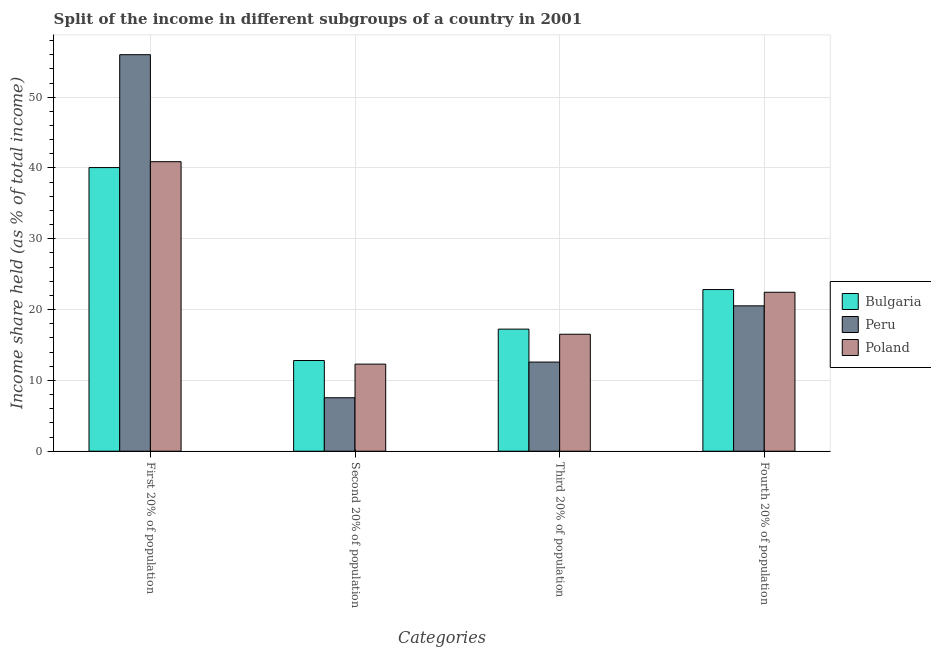Are the number of bars on each tick of the X-axis equal?
Give a very brief answer. Yes. How many bars are there on the 3rd tick from the left?
Your response must be concise. 3. How many bars are there on the 3rd tick from the right?
Provide a succinct answer. 3. What is the label of the 2nd group of bars from the left?
Your answer should be very brief. Second 20% of population. What is the share of the income held by third 20% of the population in Peru?
Your answer should be very brief. 12.59. Across all countries, what is the minimum share of the income held by third 20% of the population?
Provide a short and direct response. 12.59. In which country was the share of the income held by second 20% of the population maximum?
Give a very brief answer. Bulgaria. What is the total share of the income held by second 20% of the population in the graph?
Provide a succinct answer. 32.66. What is the difference between the share of the income held by first 20% of the population in Peru and that in Poland?
Your answer should be compact. 15.11. What is the difference between the share of the income held by fourth 20% of the population in Bulgaria and the share of the income held by third 20% of the population in Poland?
Your answer should be very brief. 6.31. What is the average share of the income held by third 20% of the population per country?
Give a very brief answer. 15.45. What is the difference between the share of the income held by third 20% of the population and share of the income held by second 20% of the population in Poland?
Give a very brief answer. 4.22. What is the ratio of the share of the income held by third 20% of the population in Bulgaria to that in Poland?
Your answer should be compact. 1.04. Is the share of the income held by second 20% of the population in Poland less than that in Peru?
Your response must be concise. No. Is the difference between the share of the income held by fourth 20% of the population in Bulgaria and Peru greater than the difference between the share of the income held by second 20% of the population in Bulgaria and Peru?
Offer a very short reply. No. What is the difference between the highest and the second highest share of the income held by first 20% of the population?
Your response must be concise. 15.11. What is the difference between the highest and the lowest share of the income held by first 20% of the population?
Your answer should be very brief. 15.94. In how many countries, is the share of the income held by first 20% of the population greater than the average share of the income held by first 20% of the population taken over all countries?
Your answer should be compact. 1. Is the sum of the share of the income held by first 20% of the population in Peru and Bulgaria greater than the maximum share of the income held by second 20% of the population across all countries?
Give a very brief answer. Yes. What does the 2nd bar from the right in First 20% of population represents?
Your answer should be very brief. Peru. How many bars are there?
Keep it short and to the point. 12. Are the values on the major ticks of Y-axis written in scientific E-notation?
Make the answer very short. No. How many legend labels are there?
Keep it short and to the point. 3. What is the title of the graph?
Keep it short and to the point. Split of the income in different subgroups of a country in 2001. What is the label or title of the X-axis?
Your answer should be very brief. Categories. What is the label or title of the Y-axis?
Ensure brevity in your answer.  Income share held (as % of total income). What is the Income share held (as % of total income) in Bulgaria in First 20% of population?
Provide a short and direct response. 40.06. What is the Income share held (as % of total income) in Poland in First 20% of population?
Ensure brevity in your answer.  40.89. What is the Income share held (as % of total income) in Bulgaria in Second 20% of population?
Offer a very short reply. 12.81. What is the Income share held (as % of total income) of Peru in Second 20% of population?
Make the answer very short. 7.55. What is the Income share held (as % of total income) in Bulgaria in Third 20% of population?
Provide a succinct answer. 17.24. What is the Income share held (as % of total income) in Peru in Third 20% of population?
Ensure brevity in your answer.  12.59. What is the Income share held (as % of total income) of Poland in Third 20% of population?
Offer a very short reply. 16.52. What is the Income share held (as % of total income) of Bulgaria in Fourth 20% of population?
Keep it short and to the point. 22.83. What is the Income share held (as % of total income) in Peru in Fourth 20% of population?
Your response must be concise. 20.53. What is the Income share held (as % of total income) of Poland in Fourth 20% of population?
Your response must be concise. 22.45. Across all Categories, what is the maximum Income share held (as % of total income) of Bulgaria?
Ensure brevity in your answer.  40.06. Across all Categories, what is the maximum Income share held (as % of total income) in Peru?
Keep it short and to the point. 56. Across all Categories, what is the maximum Income share held (as % of total income) of Poland?
Offer a terse response. 40.89. Across all Categories, what is the minimum Income share held (as % of total income) in Bulgaria?
Give a very brief answer. 12.81. Across all Categories, what is the minimum Income share held (as % of total income) in Peru?
Ensure brevity in your answer.  7.55. What is the total Income share held (as % of total income) in Bulgaria in the graph?
Provide a succinct answer. 92.94. What is the total Income share held (as % of total income) of Peru in the graph?
Give a very brief answer. 96.67. What is the total Income share held (as % of total income) of Poland in the graph?
Your answer should be very brief. 92.16. What is the difference between the Income share held (as % of total income) of Bulgaria in First 20% of population and that in Second 20% of population?
Keep it short and to the point. 27.25. What is the difference between the Income share held (as % of total income) of Peru in First 20% of population and that in Second 20% of population?
Provide a short and direct response. 48.45. What is the difference between the Income share held (as % of total income) in Poland in First 20% of population and that in Second 20% of population?
Provide a short and direct response. 28.59. What is the difference between the Income share held (as % of total income) in Bulgaria in First 20% of population and that in Third 20% of population?
Keep it short and to the point. 22.82. What is the difference between the Income share held (as % of total income) in Peru in First 20% of population and that in Third 20% of population?
Keep it short and to the point. 43.41. What is the difference between the Income share held (as % of total income) in Poland in First 20% of population and that in Third 20% of population?
Keep it short and to the point. 24.37. What is the difference between the Income share held (as % of total income) in Bulgaria in First 20% of population and that in Fourth 20% of population?
Offer a very short reply. 17.23. What is the difference between the Income share held (as % of total income) of Peru in First 20% of population and that in Fourth 20% of population?
Your answer should be compact. 35.47. What is the difference between the Income share held (as % of total income) in Poland in First 20% of population and that in Fourth 20% of population?
Your answer should be very brief. 18.44. What is the difference between the Income share held (as % of total income) of Bulgaria in Second 20% of population and that in Third 20% of population?
Keep it short and to the point. -4.43. What is the difference between the Income share held (as % of total income) of Peru in Second 20% of population and that in Third 20% of population?
Provide a succinct answer. -5.04. What is the difference between the Income share held (as % of total income) of Poland in Second 20% of population and that in Third 20% of population?
Ensure brevity in your answer.  -4.22. What is the difference between the Income share held (as % of total income) of Bulgaria in Second 20% of population and that in Fourth 20% of population?
Provide a succinct answer. -10.02. What is the difference between the Income share held (as % of total income) in Peru in Second 20% of population and that in Fourth 20% of population?
Provide a short and direct response. -12.98. What is the difference between the Income share held (as % of total income) in Poland in Second 20% of population and that in Fourth 20% of population?
Your answer should be compact. -10.15. What is the difference between the Income share held (as % of total income) in Bulgaria in Third 20% of population and that in Fourth 20% of population?
Make the answer very short. -5.59. What is the difference between the Income share held (as % of total income) in Peru in Third 20% of population and that in Fourth 20% of population?
Your answer should be compact. -7.94. What is the difference between the Income share held (as % of total income) of Poland in Third 20% of population and that in Fourth 20% of population?
Ensure brevity in your answer.  -5.93. What is the difference between the Income share held (as % of total income) of Bulgaria in First 20% of population and the Income share held (as % of total income) of Peru in Second 20% of population?
Your answer should be very brief. 32.51. What is the difference between the Income share held (as % of total income) in Bulgaria in First 20% of population and the Income share held (as % of total income) in Poland in Second 20% of population?
Ensure brevity in your answer.  27.76. What is the difference between the Income share held (as % of total income) in Peru in First 20% of population and the Income share held (as % of total income) in Poland in Second 20% of population?
Keep it short and to the point. 43.7. What is the difference between the Income share held (as % of total income) of Bulgaria in First 20% of population and the Income share held (as % of total income) of Peru in Third 20% of population?
Give a very brief answer. 27.47. What is the difference between the Income share held (as % of total income) of Bulgaria in First 20% of population and the Income share held (as % of total income) of Poland in Third 20% of population?
Provide a succinct answer. 23.54. What is the difference between the Income share held (as % of total income) in Peru in First 20% of population and the Income share held (as % of total income) in Poland in Third 20% of population?
Provide a succinct answer. 39.48. What is the difference between the Income share held (as % of total income) in Bulgaria in First 20% of population and the Income share held (as % of total income) in Peru in Fourth 20% of population?
Provide a short and direct response. 19.53. What is the difference between the Income share held (as % of total income) of Bulgaria in First 20% of population and the Income share held (as % of total income) of Poland in Fourth 20% of population?
Offer a terse response. 17.61. What is the difference between the Income share held (as % of total income) of Peru in First 20% of population and the Income share held (as % of total income) of Poland in Fourth 20% of population?
Keep it short and to the point. 33.55. What is the difference between the Income share held (as % of total income) in Bulgaria in Second 20% of population and the Income share held (as % of total income) in Peru in Third 20% of population?
Make the answer very short. 0.22. What is the difference between the Income share held (as % of total income) of Bulgaria in Second 20% of population and the Income share held (as % of total income) of Poland in Third 20% of population?
Keep it short and to the point. -3.71. What is the difference between the Income share held (as % of total income) in Peru in Second 20% of population and the Income share held (as % of total income) in Poland in Third 20% of population?
Offer a very short reply. -8.97. What is the difference between the Income share held (as % of total income) in Bulgaria in Second 20% of population and the Income share held (as % of total income) in Peru in Fourth 20% of population?
Your answer should be compact. -7.72. What is the difference between the Income share held (as % of total income) of Bulgaria in Second 20% of population and the Income share held (as % of total income) of Poland in Fourth 20% of population?
Keep it short and to the point. -9.64. What is the difference between the Income share held (as % of total income) of Peru in Second 20% of population and the Income share held (as % of total income) of Poland in Fourth 20% of population?
Keep it short and to the point. -14.9. What is the difference between the Income share held (as % of total income) of Bulgaria in Third 20% of population and the Income share held (as % of total income) of Peru in Fourth 20% of population?
Your response must be concise. -3.29. What is the difference between the Income share held (as % of total income) in Bulgaria in Third 20% of population and the Income share held (as % of total income) in Poland in Fourth 20% of population?
Give a very brief answer. -5.21. What is the difference between the Income share held (as % of total income) of Peru in Third 20% of population and the Income share held (as % of total income) of Poland in Fourth 20% of population?
Keep it short and to the point. -9.86. What is the average Income share held (as % of total income) of Bulgaria per Categories?
Make the answer very short. 23.23. What is the average Income share held (as % of total income) in Peru per Categories?
Your answer should be very brief. 24.17. What is the average Income share held (as % of total income) in Poland per Categories?
Keep it short and to the point. 23.04. What is the difference between the Income share held (as % of total income) of Bulgaria and Income share held (as % of total income) of Peru in First 20% of population?
Your answer should be compact. -15.94. What is the difference between the Income share held (as % of total income) in Bulgaria and Income share held (as % of total income) in Poland in First 20% of population?
Ensure brevity in your answer.  -0.83. What is the difference between the Income share held (as % of total income) of Peru and Income share held (as % of total income) of Poland in First 20% of population?
Give a very brief answer. 15.11. What is the difference between the Income share held (as % of total income) of Bulgaria and Income share held (as % of total income) of Peru in Second 20% of population?
Your answer should be very brief. 5.26. What is the difference between the Income share held (as % of total income) of Bulgaria and Income share held (as % of total income) of Poland in Second 20% of population?
Offer a terse response. 0.51. What is the difference between the Income share held (as % of total income) in Peru and Income share held (as % of total income) in Poland in Second 20% of population?
Make the answer very short. -4.75. What is the difference between the Income share held (as % of total income) of Bulgaria and Income share held (as % of total income) of Peru in Third 20% of population?
Provide a succinct answer. 4.65. What is the difference between the Income share held (as % of total income) in Bulgaria and Income share held (as % of total income) in Poland in Third 20% of population?
Offer a very short reply. 0.72. What is the difference between the Income share held (as % of total income) of Peru and Income share held (as % of total income) of Poland in Third 20% of population?
Your answer should be very brief. -3.93. What is the difference between the Income share held (as % of total income) of Bulgaria and Income share held (as % of total income) of Peru in Fourth 20% of population?
Offer a terse response. 2.3. What is the difference between the Income share held (as % of total income) of Bulgaria and Income share held (as % of total income) of Poland in Fourth 20% of population?
Your response must be concise. 0.38. What is the difference between the Income share held (as % of total income) in Peru and Income share held (as % of total income) in Poland in Fourth 20% of population?
Make the answer very short. -1.92. What is the ratio of the Income share held (as % of total income) of Bulgaria in First 20% of population to that in Second 20% of population?
Offer a terse response. 3.13. What is the ratio of the Income share held (as % of total income) of Peru in First 20% of population to that in Second 20% of population?
Ensure brevity in your answer.  7.42. What is the ratio of the Income share held (as % of total income) in Poland in First 20% of population to that in Second 20% of population?
Offer a terse response. 3.32. What is the ratio of the Income share held (as % of total income) of Bulgaria in First 20% of population to that in Third 20% of population?
Keep it short and to the point. 2.32. What is the ratio of the Income share held (as % of total income) of Peru in First 20% of population to that in Third 20% of population?
Your answer should be compact. 4.45. What is the ratio of the Income share held (as % of total income) of Poland in First 20% of population to that in Third 20% of population?
Your answer should be very brief. 2.48. What is the ratio of the Income share held (as % of total income) of Bulgaria in First 20% of population to that in Fourth 20% of population?
Provide a succinct answer. 1.75. What is the ratio of the Income share held (as % of total income) of Peru in First 20% of population to that in Fourth 20% of population?
Your answer should be very brief. 2.73. What is the ratio of the Income share held (as % of total income) in Poland in First 20% of population to that in Fourth 20% of population?
Your response must be concise. 1.82. What is the ratio of the Income share held (as % of total income) in Bulgaria in Second 20% of population to that in Third 20% of population?
Offer a terse response. 0.74. What is the ratio of the Income share held (as % of total income) in Peru in Second 20% of population to that in Third 20% of population?
Give a very brief answer. 0.6. What is the ratio of the Income share held (as % of total income) of Poland in Second 20% of population to that in Third 20% of population?
Keep it short and to the point. 0.74. What is the ratio of the Income share held (as % of total income) in Bulgaria in Second 20% of population to that in Fourth 20% of population?
Offer a very short reply. 0.56. What is the ratio of the Income share held (as % of total income) of Peru in Second 20% of population to that in Fourth 20% of population?
Give a very brief answer. 0.37. What is the ratio of the Income share held (as % of total income) in Poland in Second 20% of population to that in Fourth 20% of population?
Ensure brevity in your answer.  0.55. What is the ratio of the Income share held (as % of total income) of Bulgaria in Third 20% of population to that in Fourth 20% of population?
Give a very brief answer. 0.76. What is the ratio of the Income share held (as % of total income) of Peru in Third 20% of population to that in Fourth 20% of population?
Offer a very short reply. 0.61. What is the ratio of the Income share held (as % of total income) of Poland in Third 20% of population to that in Fourth 20% of population?
Your response must be concise. 0.74. What is the difference between the highest and the second highest Income share held (as % of total income) of Bulgaria?
Your answer should be very brief. 17.23. What is the difference between the highest and the second highest Income share held (as % of total income) of Peru?
Your answer should be compact. 35.47. What is the difference between the highest and the second highest Income share held (as % of total income) of Poland?
Your answer should be very brief. 18.44. What is the difference between the highest and the lowest Income share held (as % of total income) of Bulgaria?
Your answer should be very brief. 27.25. What is the difference between the highest and the lowest Income share held (as % of total income) of Peru?
Provide a succinct answer. 48.45. What is the difference between the highest and the lowest Income share held (as % of total income) in Poland?
Offer a terse response. 28.59. 